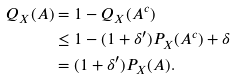Convert formula to latex. <formula><loc_0><loc_0><loc_500><loc_500>Q _ { X } ( A ) & = 1 - Q _ { X } ( A ^ { c } ) \\ & \leq 1 - ( 1 + \delta ^ { \prime } ) P _ { X } ( A ^ { c } ) + \delta \\ & = ( 1 + \delta ^ { \prime } ) P _ { X } ( A ) .</formula> 